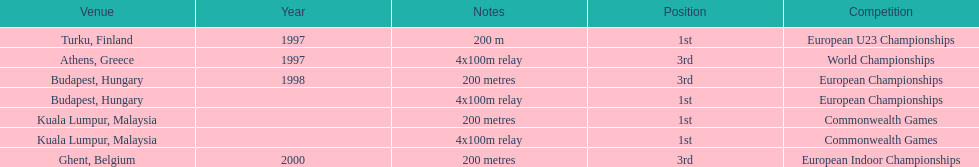How long was the sprint from the european indoor championships competition in 2000? 200 metres. 